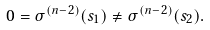<formula> <loc_0><loc_0><loc_500><loc_500>0 = \sigma ^ { ( n - 2 ) } ( s _ { 1 } ) \neq \sigma ^ { ( n - 2 ) } ( s _ { 2 } ) .</formula> 